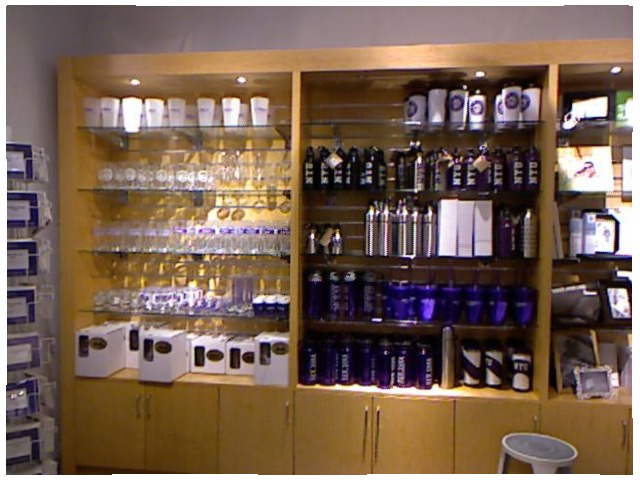<image>
Can you confirm if the cup is on the water bottle? No. The cup is not positioned on the water bottle. They may be near each other, but the cup is not supported by or resting on top of the water bottle. Where is the bottle in relation to the bottle? Is it on the bottle? No. The bottle is not positioned on the bottle. They may be near each other, but the bottle is not supported by or resting on top of the bottle. 